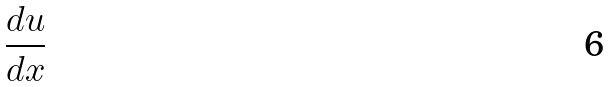Convert formula to latex. <formula><loc_0><loc_0><loc_500><loc_500>\frac { d u } { d x }</formula> 